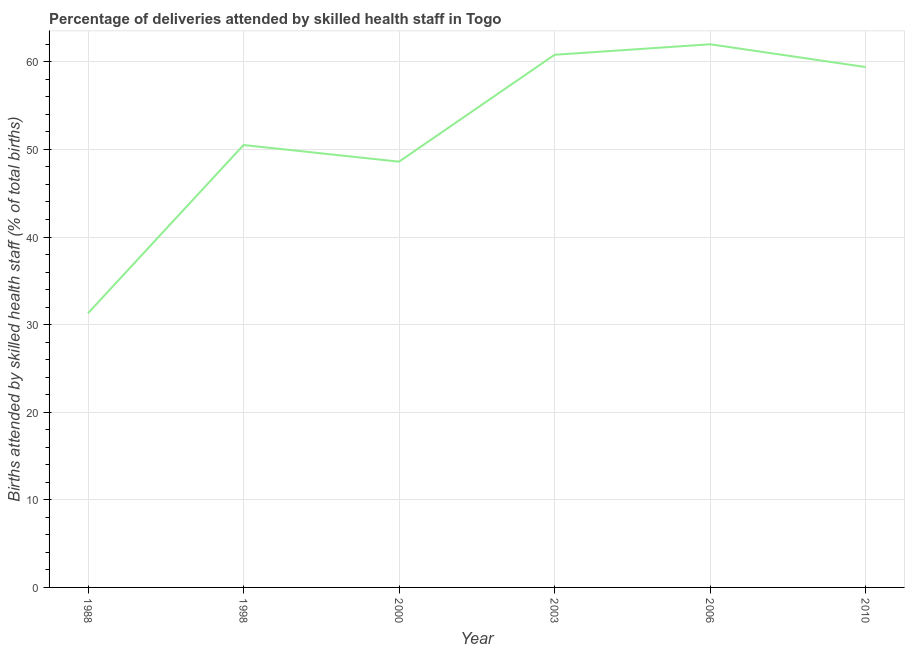What is the number of births attended by skilled health staff in 1998?
Make the answer very short. 50.5. Across all years, what is the minimum number of births attended by skilled health staff?
Give a very brief answer. 31.3. In which year was the number of births attended by skilled health staff maximum?
Ensure brevity in your answer.  2006. What is the sum of the number of births attended by skilled health staff?
Offer a terse response. 312.6. What is the difference between the number of births attended by skilled health staff in 1998 and 2010?
Your answer should be compact. -8.9. What is the average number of births attended by skilled health staff per year?
Ensure brevity in your answer.  52.1. What is the median number of births attended by skilled health staff?
Provide a succinct answer. 54.95. What is the ratio of the number of births attended by skilled health staff in 2003 to that in 2010?
Provide a short and direct response. 1.02. What is the difference between the highest and the second highest number of births attended by skilled health staff?
Give a very brief answer. 1.2. What is the difference between the highest and the lowest number of births attended by skilled health staff?
Your response must be concise. 30.7. How many years are there in the graph?
Your response must be concise. 6. What is the difference between two consecutive major ticks on the Y-axis?
Offer a terse response. 10. Are the values on the major ticks of Y-axis written in scientific E-notation?
Your answer should be very brief. No. What is the title of the graph?
Offer a very short reply. Percentage of deliveries attended by skilled health staff in Togo. What is the label or title of the X-axis?
Keep it short and to the point. Year. What is the label or title of the Y-axis?
Ensure brevity in your answer.  Births attended by skilled health staff (% of total births). What is the Births attended by skilled health staff (% of total births) of 1988?
Keep it short and to the point. 31.3. What is the Births attended by skilled health staff (% of total births) in 1998?
Give a very brief answer. 50.5. What is the Births attended by skilled health staff (% of total births) of 2000?
Provide a short and direct response. 48.6. What is the Births attended by skilled health staff (% of total births) in 2003?
Your response must be concise. 60.8. What is the Births attended by skilled health staff (% of total births) in 2006?
Offer a terse response. 62. What is the Births attended by skilled health staff (% of total births) in 2010?
Provide a succinct answer. 59.4. What is the difference between the Births attended by skilled health staff (% of total births) in 1988 and 1998?
Your answer should be very brief. -19.2. What is the difference between the Births attended by skilled health staff (% of total births) in 1988 and 2000?
Make the answer very short. -17.3. What is the difference between the Births attended by skilled health staff (% of total births) in 1988 and 2003?
Your answer should be very brief. -29.5. What is the difference between the Births attended by skilled health staff (% of total births) in 1988 and 2006?
Ensure brevity in your answer.  -30.7. What is the difference between the Births attended by skilled health staff (% of total births) in 1988 and 2010?
Your answer should be very brief. -28.1. What is the difference between the Births attended by skilled health staff (% of total births) in 1998 and 2000?
Give a very brief answer. 1.9. What is the difference between the Births attended by skilled health staff (% of total births) in 1998 and 2003?
Offer a very short reply. -10.3. What is the difference between the Births attended by skilled health staff (% of total births) in 2000 and 2003?
Provide a short and direct response. -12.2. What is the difference between the Births attended by skilled health staff (% of total births) in 2000 and 2010?
Ensure brevity in your answer.  -10.8. What is the difference between the Births attended by skilled health staff (% of total births) in 2003 and 2006?
Make the answer very short. -1.2. What is the ratio of the Births attended by skilled health staff (% of total births) in 1988 to that in 1998?
Make the answer very short. 0.62. What is the ratio of the Births attended by skilled health staff (% of total births) in 1988 to that in 2000?
Give a very brief answer. 0.64. What is the ratio of the Births attended by skilled health staff (% of total births) in 1988 to that in 2003?
Provide a short and direct response. 0.52. What is the ratio of the Births attended by skilled health staff (% of total births) in 1988 to that in 2006?
Make the answer very short. 0.51. What is the ratio of the Births attended by skilled health staff (% of total births) in 1988 to that in 2010?
Offer a terse response. 0.53. What is the ratio of the Births attended by skilled health staff (% of total births) in 1998 to that in 2000?
Your answer should be compact. 1.04. What is the ratio of the Births attended by skilled health staff (% of total births) in 1998 to that in 2003?
Give a very brief answer. 0.83. What is the ratio of the Births attended by skilled health staff (% of total births) in 1998 to that in 2006?
Offer a very short reply. 0.81. What is the ratio of the Births attended by skilled health staff (% of total births) in 2000 to that in 2003?
Offer a very short reply. 0.8. What is the ratio of the Births attended by skilled health staff (% of total births) in 2000 to that in 2006?
Provide a succinct answer. 0.78. What is the ratio of the Births attended by skilled health staff (% of total births) in 2000 to that in 2010?
Your response must be concise. 0.82. What is the ratio of the Births attended by skilled health staff (% of total births) in 2003 to that in 2010?
Your answer should be very brief. 1.02. What is the ratio of the Births attended by skilled health staff (% of total births) in 2006 to that in 2010?
Your answer should be compact. 1.04. 